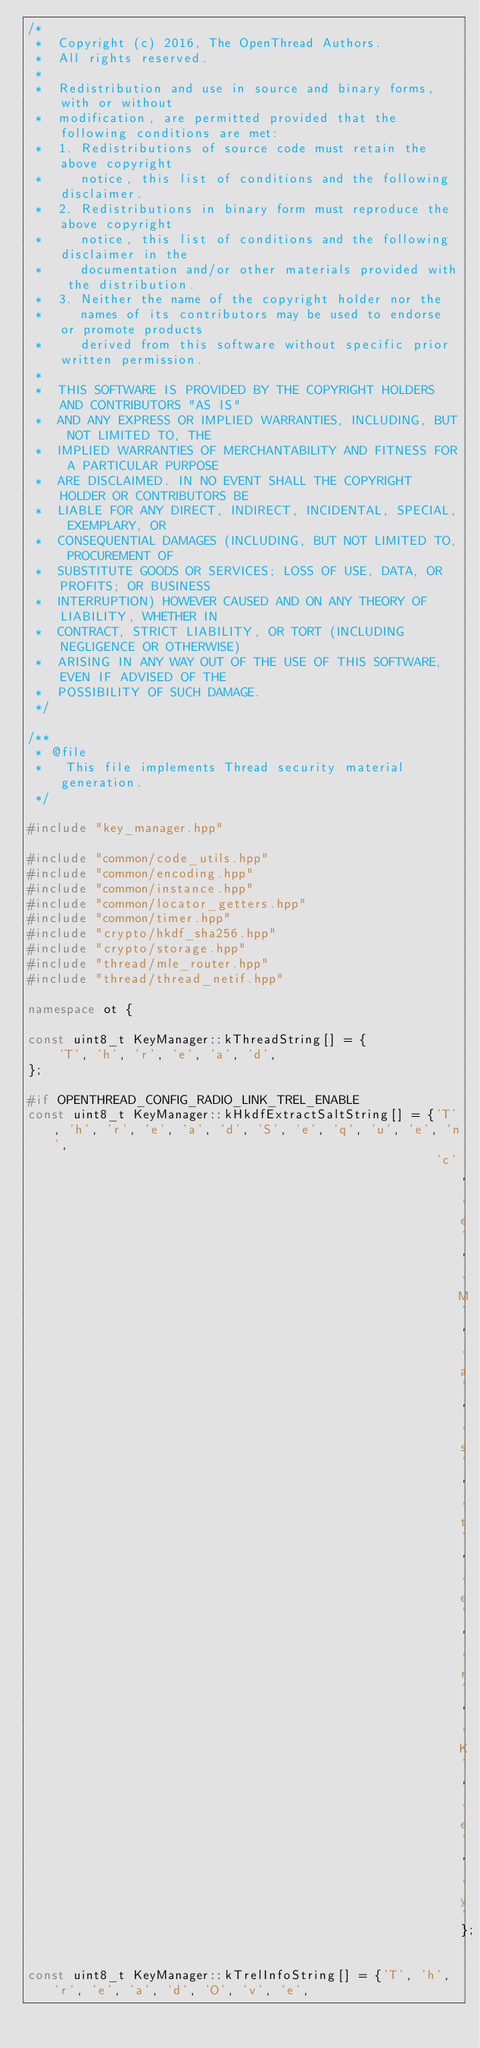Convert code to text. <code><loc_0><loc_0><loc_500><loc_500><_C++_>/*
 *  Copyright (c) 2016, The OpenThread Authors.
 *  All rights reserved.
 *
 *  Redistribution and use in source and binary forms, with or without
 *  modification, are permitted provided that the following conditions are met:
 *  1. Redistributions of source code must retain the above copyright
 *     notice, this list of conditions and the following disclaimer.
 *  2. Redistributions in binary form must reproduce the above copyright
 *     notice, this list of conditions and the following disclaimer in the
 *     documentation and/or other materials provided with the distribution.
 *  3. Neither the name of the copyright holder nor the
 *     names of its contributors may be used to endorse or promote products
 *     derived from this software without specific prior written permission.
 *
 *  THIS SOFTWARE IS PROVIDED BY THE COPYRIGHT HOLDERS AND CONTRIBUTORS "AS IS"
 *  AND ANY EXPRESS OR IMPLIED WARRANTIES, INCLUDING, BUT NOT LIMITED TO, THE
 *  IMPLIED WARRANTIES OF MERCHANTABILITY AND FITNESS FOR A PARTICULAR PURPOSE
 *  ARE DISCLAIMED. IN NO EVENT SHALL THE COPYRIGHT HOLDER OR CONTRIBUTORS BE
 *  LIABLE FOR ANY DIRECT, INDIRECT, INCIDENTAL, SPECIAL, EXEMPLARY, OR
 *  CONSEQUENTIAL DAMAGES (INCLUDING, BUT NOT LIMITED TO, PROCUREMENT OF
 *  SUBSTITUTE GOODS OR SERVICES; LOSS OF USE, DATA, OR PROFITS; OR BUSINESS
 *  INTERRUPTION) HOWEVER CAUSED AND ON ANY THEORY OF LIABILITY, WHETHER IN
 *  CONTRACT, STRICT LIABILITY, OR TORT (INCLUDING NEGLIGENCE OR OTHERWISE)
 *  ARISING IN ANY WAY OUT OF THE USE OF THIS SOFTWARE, EVEN IF ADVISED OF THE
 *  POSSIBILITY OF SUCH DAMAGE.
 */

/**
 * @file
 *   This file implements Thread security material generation.
 */

#include "key_manager.hpp"

#include "common/code_utils.hpp"
#include "common/encoding.hpp"
#include "common/instance.hpp"
#include "common/locator_getters.hpp"
#include "common/timer.hpp"
#include "crypto/hkdf_sha256.hpp"
#include "crypto/storage.hpp"
#include "thread/mle_router.hpp"
#include "thread/thread_netif.hpp"

namespace ot {

const uint8_t KeyManager::kThreadString[] = {
    'T', 'h', 'r', 'e', 'a', 'd',
};

#if OPENTHREAD_CONFIG_RADIO_LINK_TREL_ENABLE
const uint8_t KeyManager::kHkdfExtractSaltString[] = {'T', 'h', 'r', 'e', 'a', 'd', 'S', 'e', 'q', 'u', 'e', 'n',
                                                      'c', 'e', 'M', 'a', 's', 't', 'e', 'r', 'K', 'e', 'y'};

const uint8_t KeyManager::kTrelInfoString[] = {'T', 'h', 'r', 'e', 'a', 'd', 'O', 'v', 'e',</code> 